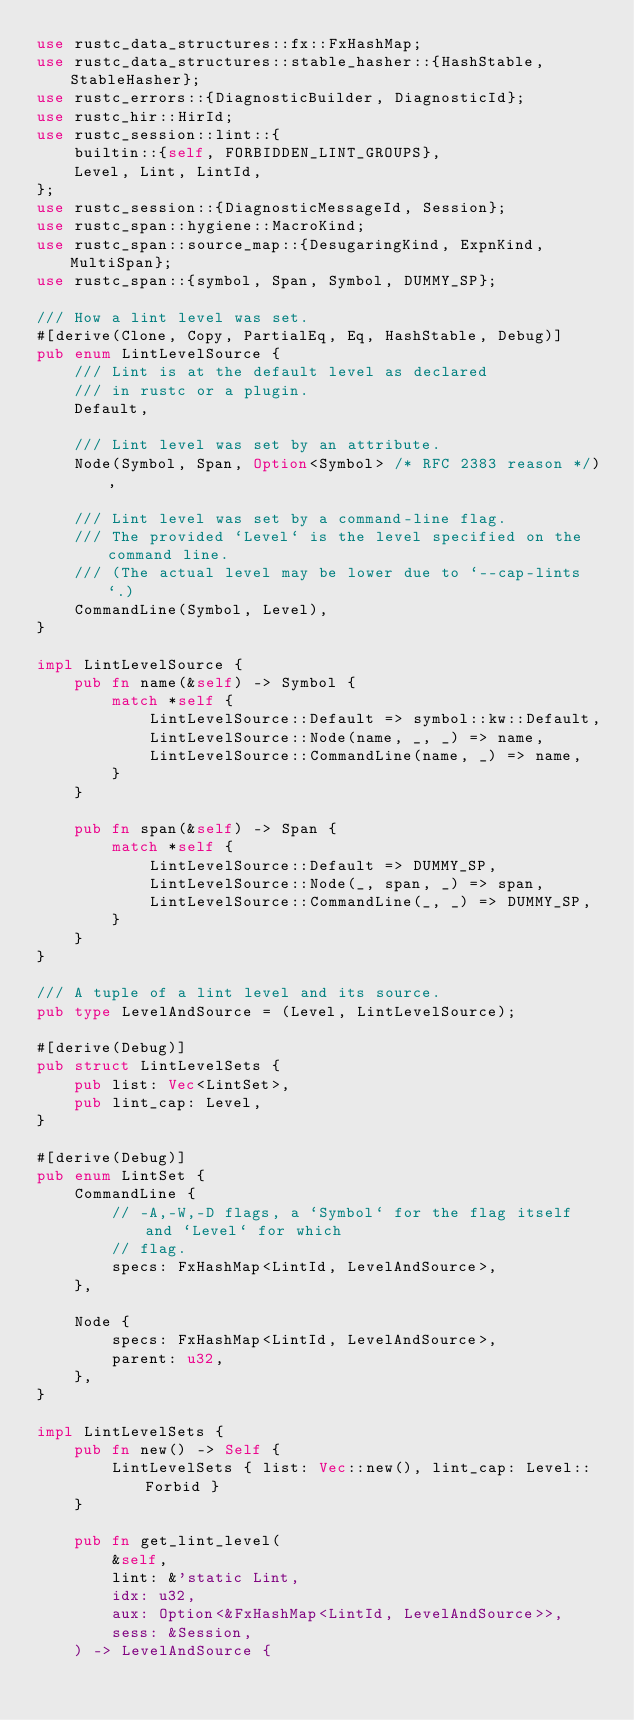Convert code to text. <code><loc_0><loc_0><loc_500><loc_500><_Rust_>use rustc_data_structures::fx::FxHashMap;
use rustc_data_structures::stable_hasher::{HashStable, StableHasher};
use rustc_errors::{DiagnosticBuilder, DiagnosticId};
use rustc_hir::HirId;
use rustc_session::lint::{
    builtin::{self, FORBIDDEN_LINT_GROUPS},
    Level, Lint, LintId,
};
use rustc_session::{DiagnosticMessageId, Session};
use rustc_span::hygiene::MacroKind;
use rustc_span::source_map::{DesugaringKind, ExpnKind, MultiSpan};
use rustc_span::{symbol, Span, Symbol, DUMMY_SP};

/// How a lint level was set.
#[derive(Clone, Copy, PartialEq, Eq, HashStable, Debug)]
pub enum LintLevelSource {
    /// Lint is at the default level as declared
    /// in rustc or a plugin.
    Default,

    /// Lint level was set by an attribute.
    Node(Symbol, Span, Option<Symbol> /* RFC 2383 reason */),

    /// Lint level was set by a command-line flag.
    /// The provided `Level` is the level specified on the command line.
    /// (The actual level may be lower due to `--cap-lints`.)
    CommandLine(Symbol, Level),
}

impl LintLevelSource {
    pub fn name(&self) -> Symbol {
        match *self {
            LintLevelSource::Default => symbol::kw::Default,
            LintLevelSource::Node(name, _, _) => name,
            LintLevelSource::CommandLine(name, _) => name,
        }
    }

    pub fn span(&self) -> Span {
        match *self {
            LintLevelSource::Default => DUMMY_SP,
            LintLevelSource::Node(_, span, _) => span,
            LintLevelSource::CommandLine(_, _) => DUMMY_SP,
        }
    }
}

/// A tuple of a lint level and its source.
pub type LevelAndSource = (Level, LintLevelSource);

#[derive(Debug)]
pub struct LintLevelSets {
    pub list: Vec<LintSet>,
    pub lint_cap: Level,
}

#[derive(Debug)]
pub enum LintSet {
    CommandLine {
        // -A,-W,-D flags, a `Symbol` for the flag itself and `Level` for which
        // flag.
        specs: FxHashMap<LintId, LevelAndSource>,
    },

    Node {
        specs: FxHashMap<LintId, LevelAndSource>,
        parent: u32,
    },
}

impl LintLevelSets {
    pub fn new() -> Self {
        LintLevelSets { list: Vec::new(), lint_cap: Level::Forbid }
    }

    pub fn get_lint_level(
        &self,
        lint: &'static Lint,
        idx: u32,
        aux: Option<&FxHashMap<LintId, LevelAndSource>>,
        sess: &Session,
    ) -> LevelAndSource {</code> 